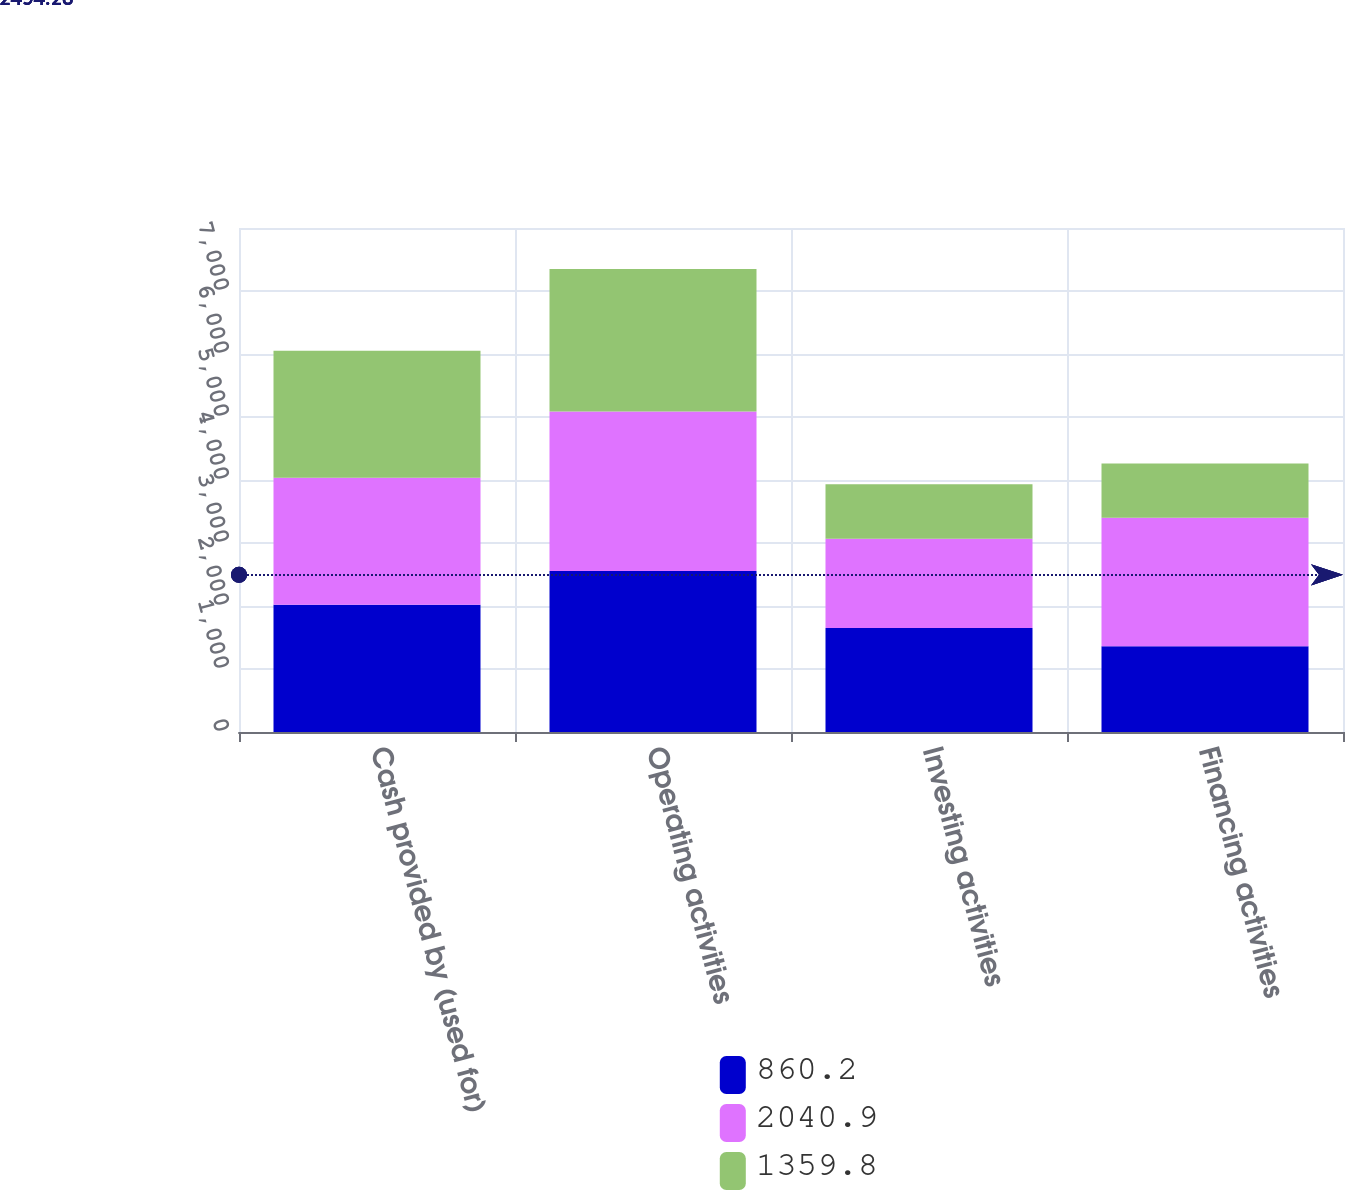<chart> <loc_0><loc_0><loc_500><loc_500><stacked_bar_chart><ecel><fcel>Cash provided by (used for)<fcel>Operating activities<fcel>Investing activities<fcel>Financing activities<nl><fcel>860.2<fcel>2018<fcel>2554.7<fcel>1649.1<fcel>1359.8<nl><fcel>2040.9<fcel>2017<fcel>2534.1<fcel>1417.7<fcel>2040.9<nl><fcel>1359.8<fcel>2016<fcel>2258.8<fcel>864.8<fcel>860.2<nl></chart> 